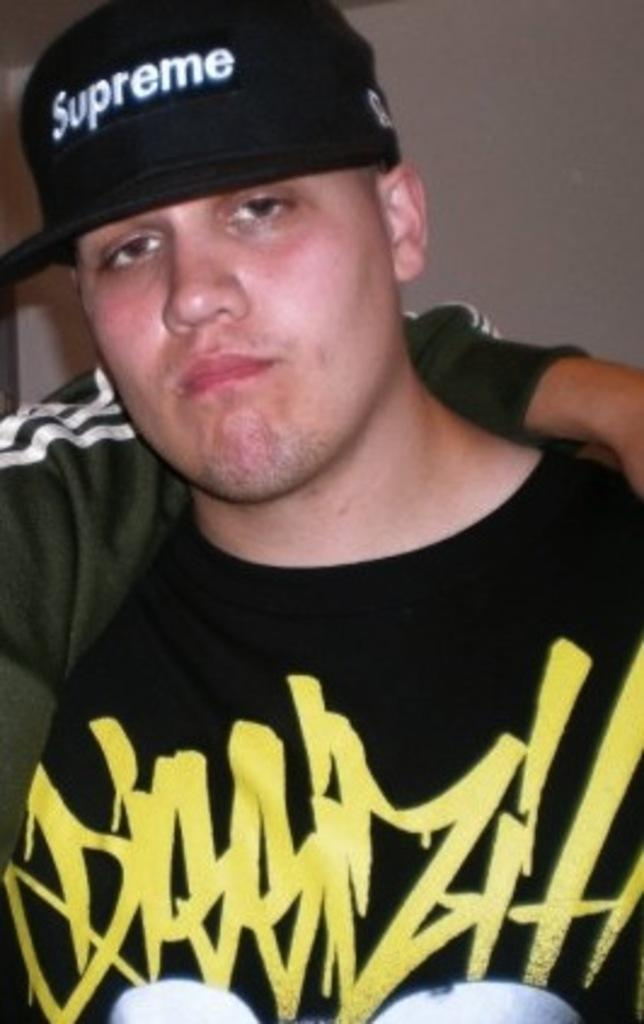<image>
Relay a brief, clear account of the picture shown. A young man wearing the brand Supreme on a black cap. 